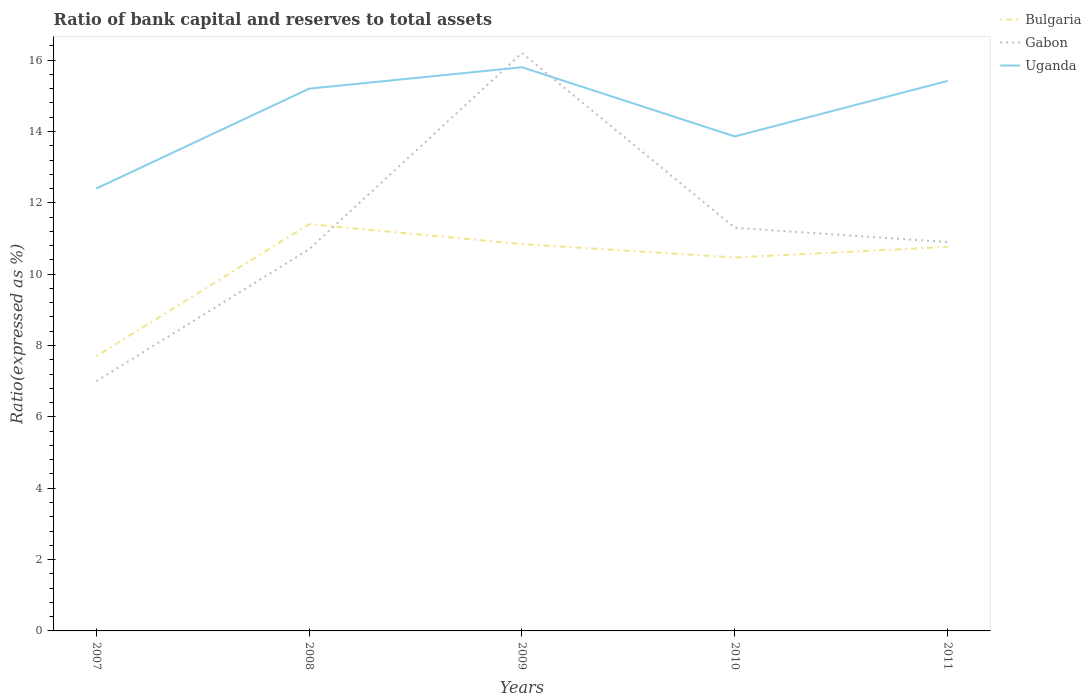How many different coloured lines are there?
Give a very brief answer. 3. Does the line corresponding to Gabon intersect with the line corresponding to Uganda?
Provide a short and direct response. Yes. Is the number of lines equal to the number of legend labels?
Keep it short and to the point. Yes. Across all years, what is the maximum ratio of bank capital and reserves to total assets in Uganda?
Ensure brevity in your answer.  12.4. What is the total ratio of bank capital and reserves to total assets in Bulgaria in the graph?
Make the answer very short. 0.08. What is the difference between the highest and the second highest ratio of bank capital and reserves to total assets in Uganda?
Your answer should be compact. 3.4. What is the difference between the highest and the lowest ratio of bank capital and reserves to total assets in Bulgaria?
Provide a short and direct response. 4. Is the ratio of bank capital and reserves to total assets in Gabon strictly greater than the ratio of bank capital and reserves to total assets in Uganda over the years?
Offer a terse response. No. How many lines are there?
Offer a terse response. 3. How many years are there in the graph?
Your response must be concise. 5. Does the graph contain any zero values?
Provide a short and direct response. No. Where does the legend appear in the graph?
Offer a very short reply. Top right. How many legend labels are there?
Offer a terse response. 3. What is the title of the graph?
Your answer should be very brief. Ratio of bank capital and reserves to total assets. What is the label or title of the X-axis?
Ensure brevity in your answer.  Years. What is the label or title of the Y-axis?
Provide a short and direct response. Ratio(expressed as %). What is the Ratio(expressed as %) of Uganda in 2007?
Give a very brief answer. 12.4. What is the Ratio(expressed as %) of Bulgaria in 2008?
Offer a terse response. 11.4. What is the Ratio(expressed as %) of Uganda in 2008?
Ensure brevity in your answer.  15.2. What is the Ratio(expressed as %) in Bulgaria in 2009?
Provide a short and direct response. 10.84. What is the Ratio(expressed as %) of Bulgaria in 2010?
Your answer should be very brief. 10.47. What is the Ratio(expressed as %) in Gabon in 2010?
Keep it short and to the point. 11.3. What is the Ratio(expressed as %) in Uganda in 2010?
Offer a very short reply. 13.86. What is the Ratio(expressed as %) in Bulgaria in 2011?
Provide a short and direct response. 10.76. What is the Ratio(expressed as %) of Gabon in 2011?
Your answer should be compact. 10.9. What is the Ratio(expressed as %) of Uganda in 2011?
Your answer should be compact. 15.42. Across all years, what is the maximum Ratio(expressed as %) in Bulgaria?
Give a very brief answer. 11.4. Across all years, what is the maximum Ratio(expressed as %) of Uganda?
Keep it short and to the point. 15.8. Across all years, what is the minimum Ratio(expressed as %) of Bulgaria?
Your answer should be very brief. 7.7. What is the total Ratio(expressed as %) in Bulgaria in the graph?
Your response must be concise. 51.18. What is the total Ratio(expressed as %) in Gabon in the graph?
Your answer should be compact. 56.1. What is the total Ratio(expressed as %) of Uganda in the graph?
Offer a terse response. 72.68. What is the difference between the Ratio(expressed as %) in Bulgaria in 2007 and that in 2008?
Your response must be concise. -3.7. What is the difference between the Ratio(expressed as %) in Bulgaria in 2007 and that in 2009?
Give a very brief answer. -3.14. What is the difference between the Ratio(expressed as %) in Bulgaria in 2007 and that in 2010?
Ensure brevity in your answer.  -2.77. What is the difference between the Ratio(expressed as %) of Uganda in 2007 and that in 2010?
Provide a succinct answer. -1.46. What is the difference between the Ratio(expressed as %) of Bulgaria in 2007 and that in 2011?
Your answer should be very brief. -3.06. What is the difference between the Ratio(expressed as %) of Uganda in 2007 and that in 2011?
Provide a succinct answer. -3.02. What is the difference between the Ratio(expressed as %) of Bulgaria in 2008 and that in 2009?
Give a very brief answer. 0.56. What is the difference between the Ratio(expressed as %) in Uganda in 2008 and that in 2009?
Make the answer very short. -0.6. What is the difference between the Ratio(expressed as %) in Bulgaria in 2008 and that in 2010?
Provide a short and direct response. 0.93. What is the difference between the Ratio(expressed as %) in Uganda in 2008 and that in 2010?
Give a very brief answer. 1.34. What is the difference between the Ratio(expressed as %) of Bulgaria in 2008 and that in 2011?
Provide a short and direct response. 0.64. What is the difference between the Ratio(expressed as %) of Gabon in 2008 and that in 2011?
Your answer should be very brief. -0.2. What is the difference between the Ratio(expressed as %) of Uganda in 2008 and that in 2011?
Offer a very short reply. -0.22. What is the difference between the Ratio(expressed as %) in Bulgaria in 2009 and that in 2010?
Offer a terse response. 0.37. What is the difference between the Ratio(expressed as %) of Gabon in 2009 and that in 2010?
Provide a succinct answer. 4.9. What is the difference between the Ratio(expressed as %) of Uganda in 2009 and that in 2010?
Your answer should be compact. 1.94. What is the difference between the Ratio(expressed as %) of Bulgaria in 2009 and that in 2011?
Make the answer very short. 0.08. What is the difference between the Ratio(expressed as %) of Uganda in 2009 and that in 2011?
Make the answer very short. 0.38. What is the difference between the Ratio(expressed as %) of Bulgaria in 2010 and that in 2011?
Offer a terse response. -0.3. What is the difference between the Ratio(expressed as %) in Uganda in 2010 and that in 2011?
Your answer should be very brief. -1.56. What is the difference between the Ratio(expressed as %) in Gabon in 2007 and the Ratio(expressed as %) in Uganda in 2008?
Make the answer very short. -8.2. What is the difference between the Ratio(expressed as %) in Bulgaria in 2007 and the Ratio(expressed as %) in Gabon in 2009?
Make the answer very short. -8.5. What is the difference between the Ratio(expressed as %) in Bulgaria in 2007 and the Ratio(expressed as %) in Uganda in 2010?
Ensure brevity in your answer.  -6.16. What is the difference between the Ratio(expressed as %) in Gabon in 2007 and the Ratio(expressed as %) in Uganda in 2010?
Your answer should be compact. -6.86. What is the difference between the Ratio(expressed as %) of Bulgaria in 2007 and the Ratio(expressed as %) of Gabon in 2011?
Ensure brevity in your answer.  -3.2. What is the difference between the Ratio(expressed as %) in Bulgaria in 2007 and the Ratio(expressed as %) in Uganda in 2011?
Your response must be concise. -7.72. What is the difference between the Ratio(expressed as %) in Gabon in 2007 and the Ratio(expressed as %) in Uganda in 2011?
Make the answer very short. -8.42. What is the difference between the Ratio(expressed as %) of Bulgaria in 2008 and the Ratio(expressed as %) of Gabon in 2009?
Offer a terse response. -4.8. What is the difference between the Ratio(expressed as %) in Bulgaria in 2008 and the Ratio(expressed as %) in Uganda in 2009?
Your response must be concise. -4.4. What is the difference between the Ratio(expressed as %) in Bulgaria in 2008 and the Ratio(expressed as %) in Gabon in 2010?
Make the answer very short. 0.1. What is the difference between the Ratio(expressed as %) of Bulgaria in 2008 and the Ratio(expressed as %) of Uganda in 2010?
Make the answer very short. -2.46. What is the difference between the Ratio(expressed as %) of Gabon in 2008 and the Ratio(expressed as %) of Uganda in 2010?
Give a very brief answer. -3.16. What is the difference between the Ratio(expressed as %) in Bulgaria in 2008 and the Ratio(expressed as %) in Gabon in 2011?
Give a very brief answer. 0.5. What is the difference between the Ratio(expressed as %) of Bulgaria in 2008 and the Ratio(expressed as %) of Uganda in 2011?
Give a very brief answer. -4.02. What is the difference between the Ratio(expressed as %) of Gabon in 2008 and the Ratio(expressed as %) of Uganda in 2011?
Provide a succinct answer. -4.72. What is the difference between the Ratio(expressed as %) of Bulgaria in 2009 and the Ratio(expressed as %) of Gabon in 2010?
Your answer should be compact. -0.46. What is the difference between the Ratio(expressed as %) in Bulgaria in 2009 and the Ratio(expressed as %) in Uganda in 2010?
Provide a succinct answer. -3.02. What is the difference between the Ratio(expressed as %) of Gabon in 2009 and the Ratio(expressed as %) of Uganda in 2010?
Provide a short and direct response. 2.34. What is the difference between the Ratio(expressed as %) of Bulgaria in 2009 and the Ratio(expressed as %) of Gabon in 2011?
Ensure brevity in your answer.  -0.06. What is the difference between the Ratio(expressed as %) in Bulgaria in 2009 and the Ratio(expressed as %) in Uganda in 2011?
Offer a very short reply. -4.58. What is the difference between the Ratio(expressed as %) in Gabon in 2009 and the Ratio(expressed as %) in Uganda in 2011?
Give a very brief answer. 0.78. What is the difference between the Ratio(expressed as %) in Bulgaria in 2010 and the Ratio(expressed as %) in Gabon in 2011?
Your response must be concise. -0.43. What is the difference between the Ratio(expressed as %) in Bulgaria in 2010 and the Ratio(expressed as %) in Uganda in 2011?
Offer a very short reply. -4.95. What is the difference between the Ratio(expressed as %) of Gabon in 2010 and the Ratio(expressed as %) of Uganda in 2011?
Keep it short and to the point. -4.12. What is the average Ratio(expressed as %) in Bulgaria per year?
Make the answer very short. 10.24. What is the average Ratio(expressed as %) in Gabon per year?
Your response must be concise. 11.22. What is the average Ratio(expressed as %) of Uganda per year?
Your answer should be very brief. 14.54. In the year 2007, what is the difference between the Ratio(expressed as %) of Bulgaria and Ratio(expressed as %) of Gabon?
Your response must be concise. 0.7. In the year 2007, what is the difference between the Ratio(expressed as %) of Gabon and Ratio(expressed as %) of Uganda?
Keep it short and to the point. -5.4. In the year 2008, what is the difference between the Ratio(expressed as %) in Bulgaria and Ratio(expressed as %) in Gabon?
Provide a succinct answer. 0.7. In the year 2008, what is the difference between the Ratio(expressed as %) in Bulgaria and Ratio(expressed as %) in Uganda?
Ensure brevity in your answer.  -3.8. In the year 2009, what is the difference between the Ratio(expressed as %) in Bulgaria and Ratio(expressed as %) in Gabon?
Give a very brief answer. -5.36. In the year 2009, what is the difference between the Ratio(expressed as %) in Bulgaria and Ratio(expressed as %) in Uganda?
Your response must be concise. -4.96. In the year 2009, what is the difference between the Ratio(expressed as %) of Gabon and Ratio(expressed as %) of Uganda?
Offer a very short reply. 0.4. In the year 2010, what is the difference between the Ratio(expressed as %) in Bulgaria and Ratio(expressed as %) in Gabon?
Provide a succinct answer. -0.83. In the year 2010, what is the difference between the Ratio(expressed as %) in Bulgaria and Ratio(expressed as %) in Uganda?
Give a very brief answer. -3.39. In the year 2010, what is the difference between the Ratio(expressed as %) of Gabon and Ratio(expressed as %) of Uganda?
Give a very brief answer. -2.56. In the year 2011, what is the difference between the Ratio(expressed as %) of Bulgaria and Ratio(expressed as %) of Gabon?
Make the answer very short. -0.14. In the year 2011, what is the difference between the Ratio(expressed as %) of Bulgaria and Ratio(expressed as %) of Uganda?
Give a very brief answer. -4.65. In the year 2011, what is the difference between the Ratio(expressed as %) of Gabon and Ratio(expressed as %) of Uganda?
Your response must be concise. -4.52. What is the ratio of the Ratio(expressed as %) in Bulgaria in 2007 to that in 2008?
Provide a succinct answer. 0.68. What is the ratio of the Ratio(expressed as %) in Gabon in 2007 to that in 2008?
Offer a very short reply. 0.65. What is the ratio of the Ratio(expressed as %) of Uganda in 2007 to that in 2008?
Offer a very short reply. 0.82. What is the ratio of the Ratio(expressed as %) in Bulgaria in 2007 to that in 2009?
Offer a terse response. 0.71. What is the ratio of the Ratio(expressed as %) of Gabon in 2007 to that in 2009?
Your answer should be very brief. 0.43. What is the ratio of the Ratio(expressed as %) of Uganda in 2007 to that in 2009?
Your response must be concise. 0.78. What is the ratio of the Ratio(expressed as %) of Bulgaria in 2007 to that in 2010?
Give a very brief answer. 0.74. What is the ratio of the Ratio(expressed as %) in Gabon in 2007 to that in 2010?
Keep it short and to the point. 0.62. What is the ratio of the Ratio(expressed as %) of Uganda in 2007 to that in 2010?
Your answer should be very brief. 0.89. What is the ratio of the Ratio(expressed as %) in Bulgaria in 2007 to that in 2011?
Give a very brief answer. 0.72. What is the ratio of the Ratio(expressed as %) in Gabon in 2007 to that in 2011?
Your response must be concise. 0.64. What is the ratio of the Ratio(expressed as %) in Uganda in 2007 to that in 2011?
Your answer should be compact. 0.8. What is the ratio of the Ratio(expressed as %) of Bulgaria in 2008 to that in 2009?
Provide a succinct answer. 1.05. What is the ratio of the Ratio(expressed as %) of Gabon in 2008 to that in 2009?
Make the answer very short. 0.66. What is the ratio of the Ratio(expressed as %) of Uganda in 2008 to that in 2009?
Offer a terse response. 0.96. What is the ratio of the Ratio(expressed as %) of Bulgaria in 2008 to that in 2010?
Offer a terse response. 1.09. What is the ratio of the Ratio(expressed as %) in Gabon in 2008 to that in 2010?
Your answer should be very brief. 0.95. What is the ratio of the Ratio(expressed as %) in Uganda in 2008 to that in 2010?
Offer a very short reply. 1.1. What is the ratio of the Ratio(expressed as %) of Bulgaria in 2008 to that in 2011?
Provide a succinct answer. 1.06. What is the ratio of the Ratio(expressed as %) of Gabon in 2008 to that in 2011?
Provide a short and direct response. 0.98. What is the ratio of the Ratio(expressed as %) of Uganda in 2008 to that in 2011?
Offer a terse response. 0.99. What is the ratio of the Ratio(expressed as %) in Bulgaria in 2009 to that in 2010?
Give a very brief answer. 1.04. What is the ratio of the Ratio(expressed as %) in Gabon in 2009 to that in 2010?
Keep it short and to the point. 1.43. What is the ratio of the Ratio(expressed as %) of Uganda in 2009 to that in 2010?
Ensure brevity in your answer.  1.14. What is the ratio of the Ratio(expressed as %) of Gabon in 2009 to that in 2011?
Your answer should be very brief. 1.49. What is the ratio of the Ratio(expressed as %) in Uganda in 2009 to that in 2011?
Provide a succinct answer. 1.02. What is the ratio of the Ratio(expressed as %) in Bulgaria in 2010 to that in 2011?
Provide a short and direct response. 0.97. What is the ratio of the Ratio(expressed as %) of Gabon in 2010 to that in 2011?
Keep it short and to the point. 1.04. What is the ratio of the Ratio(expressed as %) in Uganda in 2010 to that in 2011?
Offer a terse response. 0.9. What is the difference between the highest and the second highest Ratio(expressed as %) in Bulgaria?
Your answer should be very brief. 0.56. What is the difference between the highest and the second highest Ratio(expressed as %) of Uganda?
Keep it short and to the point. 0.38. What is the difference between the highest and the lowest Ratio(expressed as %) in Bulgaria?
Provide a succinct answer. 3.7. What is the difference between the highest and the lowest Ratio(expressed as %) in Gabon?
Your answer should be compact. 9.2. 